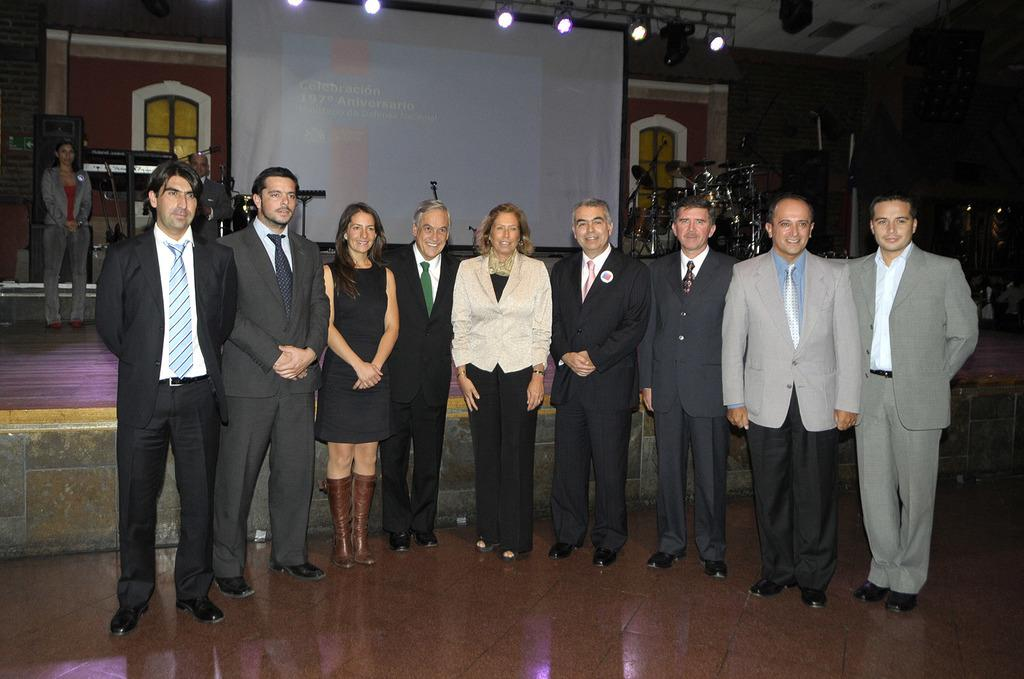What are the people in the foreground of the image doing? The people in the foreground of the image are standing on the floor. What can be seen in the background of the image? In the background, there are people, musical instruments, lights, a screen, a stage, windows, a wall, and objects. Can you describe the setting of the image? The image appears to be set in a performance or event space, with a stage, lights, and musical instruments visible. What time of day is it in the image, and how many kittens are visible? The time of day cannot be determined from the image, and there are no kittens visible. 